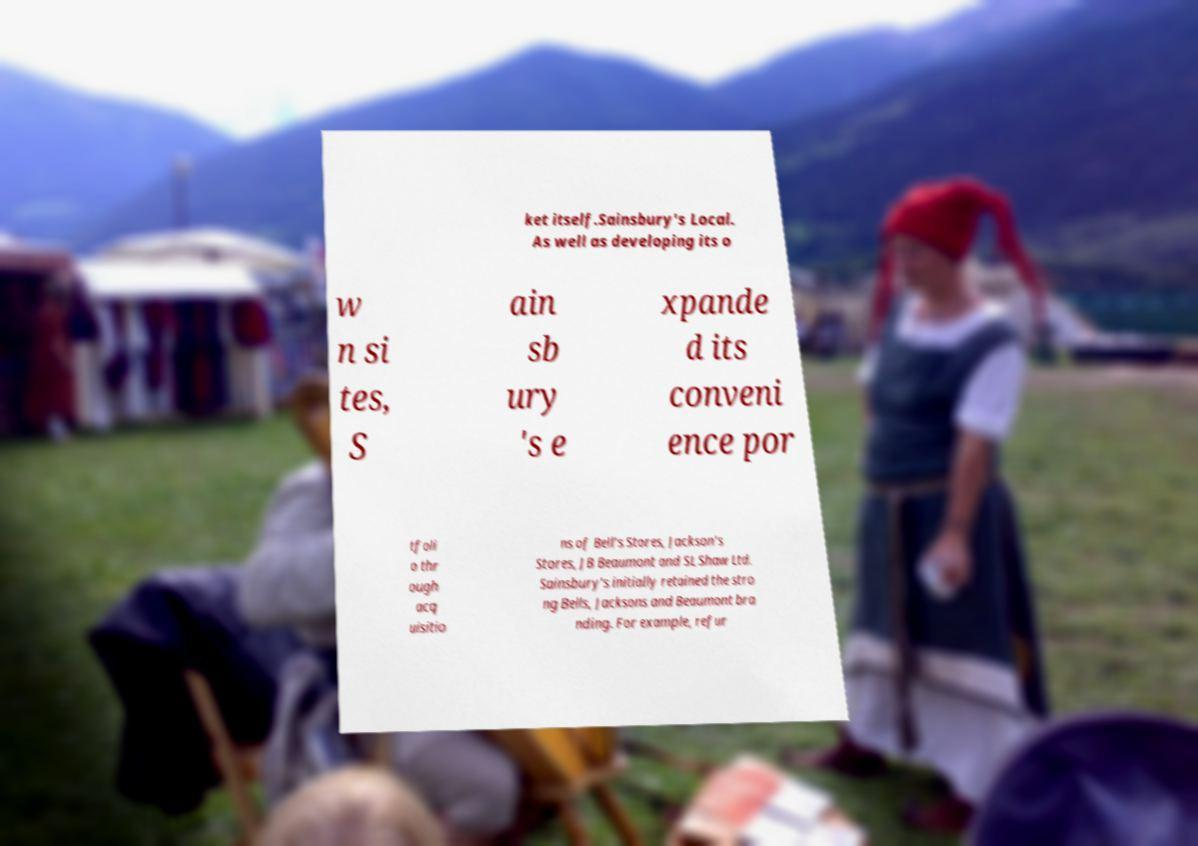I need the written content from this picture converted into text. Can you do that? ket itself.Sainsbury's Local. As well as developing its o w n si tes, S ain sb ury 's e xpande d its conveni ence por tfoli o thr ough acq uisitio ns of Bell's Stores, Jackson's Stores, JB Beaumont and SL Shaw Ltd. Sainsbury's initially retained the stro ng Bells, Jacksons and Beaumont bra nding. For example, refur 